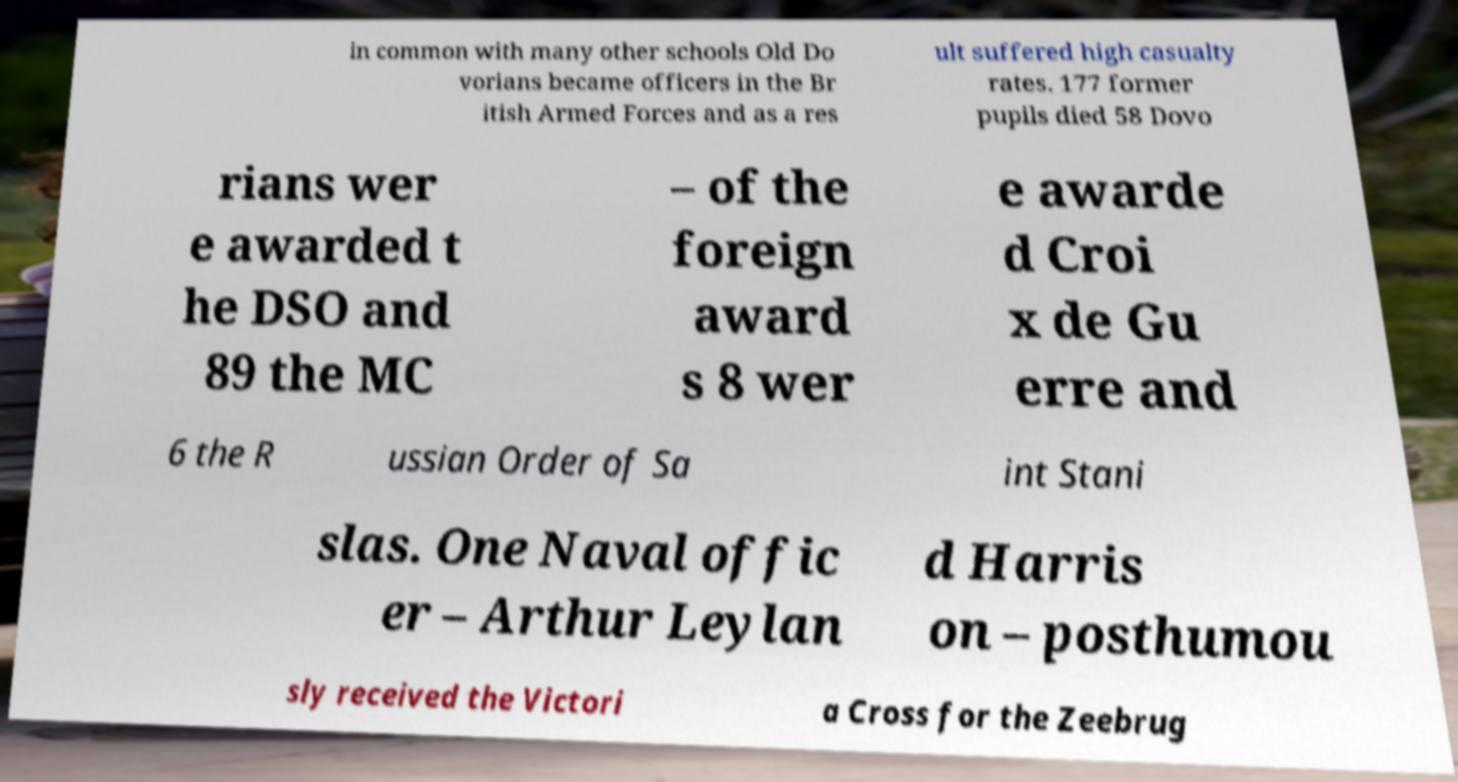Can you read and provide the text displayed in the image?This photo seems to have some interesting text. Can you extract and type it out for me? in common with many other schools Old Do vorians became officers in the Br itish Armed Forces and as a res ult suffered high casualty rates. 177 former pupils died 58 Dovo rians wer e awarded t he DSO and 89 the MC – of the foreign award s 8 wer e awarde d Croi x de Gu erre and 6 the R ussian Order of Sa int Stani slas. One Naval offic er – Arthur Leylan d Harris on – posthumou sly received the Victori a Cross for the Zeebrug 